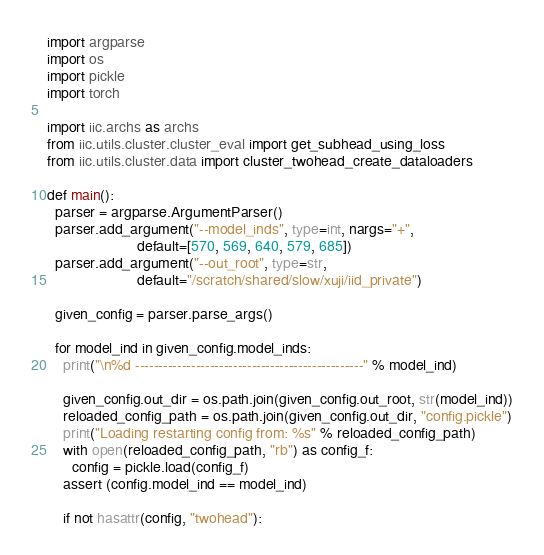Convert code to text. <code><loc_0><loc_0><loc_500><loc_500><_Python_>import argparse
import os
import pickle
import torch

import iic.archs as archs
from iic.utils.cluster.cluster_eval import get_subhead_using_loss
from iic.utils.cluster.data import cluster_twohead_create_dataloaders

def main():
  parser = argparse.ArgumentParser()
  parser.add_argument("--model_inds", type=int, nargs="+",
                      default=[570, 569, 640, 579, 685])
  parser.add_argument("--out_root", type=str,
                      default="/scratch/shared/slow/xuji/iid_private")

  given_config = parser.parse_args()

  for model_ind in given_config.model_inds:
    print("\n%d -------------------------------------------------" % model_ind)

    given_config.out_dir = os.path.join(given_config.out_root, str(model_ind))
    reloaded_config_path = os.path.join(given_config.out_dir, "config.pickle")
    print("Loading restarting config from: %s" % reloaded_config_path)
    with open(reloaded_config_path, "rb") as config_f:
      config = pickle.load(config_f)
    assert (config.model_ind == model_ind)

    if not hasattr(config, "twohead"):</code> 